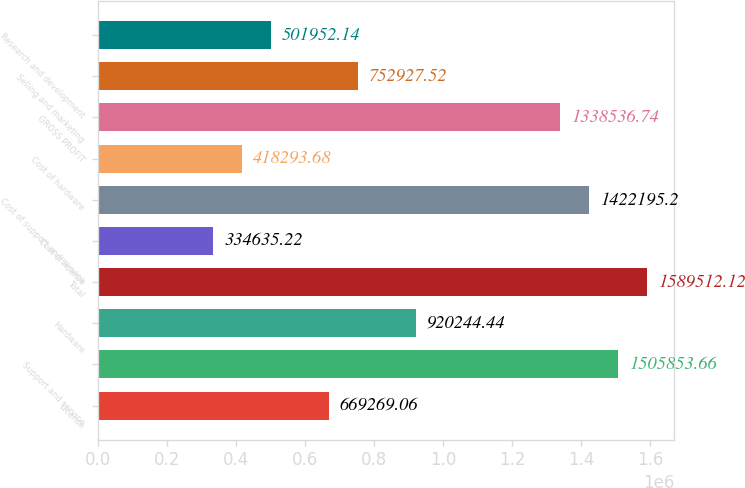Convert chart to OTSL. <chart><loc_0><loc_0><loc_500><loc_500><bar_chart><fcel>License<fcel>Support and service<fcel>Hardware<fcel>Total<fcel>Cost of license<fcel>Cost of support and service<fcel>Cost of hardware<fcel>GROSS PROFIT<fcel>Selling and marketing<fcel>Research and development<nl><fcel>669269<fcel>1.50585e+06<fcel>920244<fcel>1.58951e+06<fcel>334635<fcel>1.4222e+06<fcel>418294<fcel>1.33854e+06<fcel>752928<fcel>501952<nl></chart> 